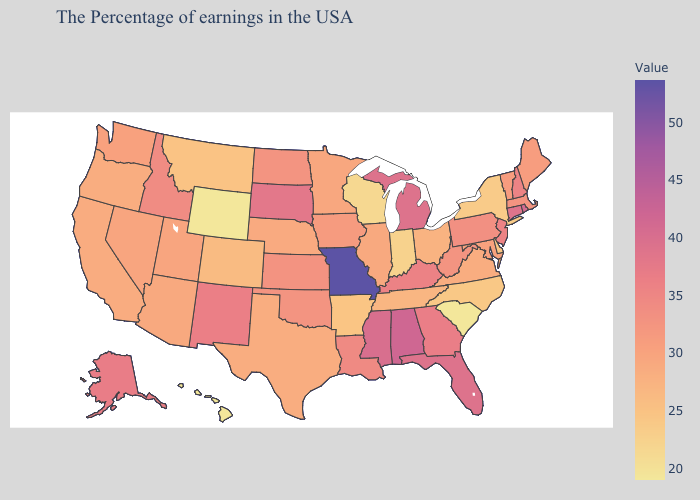Which states have the lowest value in the USA?
Write a very short answer. South Carolina, Wyoming. Which states have the lowest value in the Northeast?
Write a very short answer. New York. Does Washington have a higher value than New Jersey?
Keep it brief. No. Which states have the highest value in the USA?
Be succinct. Missouri. 